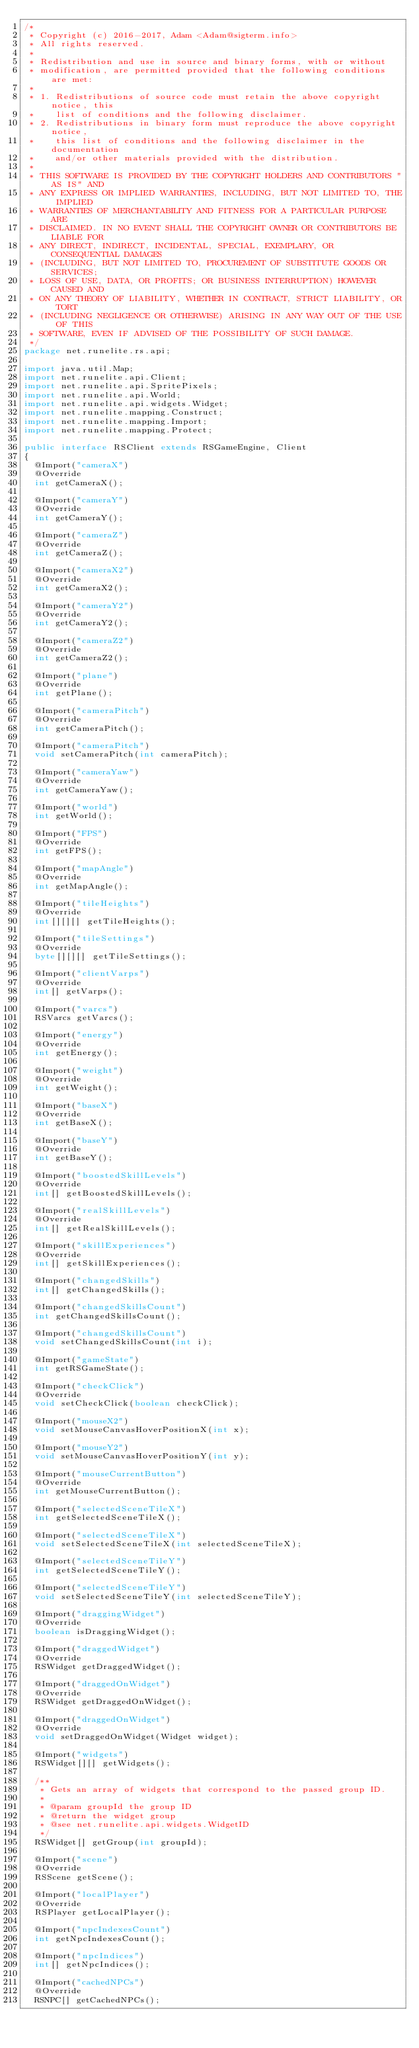<code> <loc_0><loc_0><loc_500><loc_500><_Java_>/*
 * Copyright (c) 2016-2017, Adam <Adam@sigterm.info>
 * All rights reserved.
 *
 * Redistribution and use in source and binary forms, with or without
 * modification, are permitted provided that the following conditions are met:
 *
 * 1. Redistributions of source code must retain the above copyright notice, this
 *    list of conditions and the following disclaimer.
 * 2. Redistributions in binary form must reproduce the above copyright notice,
 *    this list of conditions and the following disclaimer in the documentation
 *    and/or other materials provided with the distribution.
 *
 * THIS SOFTWARE IS PROVIDED BY THE COPYRIGHT HOLDERS AND CONTRIBUTORS "AS IS" AND
 * ANY EXPRESS OR IMPLIED WARRANTIES, INCLUDING, BUT NOT LIMITED TO, THE IMPLIED
 * WARRANTIES OF MERCHANTABILITY AND FITNESS FOR A PARTICULAR PURPOSE ARE
 * DISCLAIMED. IN NO EVENT SHALL THE COPYRIGHT OWNER OR CONTRIBUTORS BE LIABLE FOR
 * ANY DIRECT, INDIRECT, INCIDENTAL, SPECIAL, EXEMPLARY, OR CONSEQUENTIAL DAMAGES
 * (INCLUDING, BUT NOT LIMITED TO, PROCUREMENT OF SUBSTITUTE GOODS OR SERVICES;
 * LOSS OF USE, DATA, OR PROFITS; OR BUSINESS INTERRUPTION) HOWEVER CAUSED AND
 * ON ANY THEORY OF LIABILITY, WHETHER IN CONTRACT, STRICT LIABILITY, OR TORT
 * (INCLUDING NEGLIGENCE OR OTHERWISE) ARISING IN ANY WAY OUT OF THE USE OF THIS
 * SOFTWARE, EVEN IF ADVISED OF THE POSSIBILITY OF SUCH DAMAGE.
 */
package net.runelite.rs.api;

import java.util.Map;
import net.runelite.api.Client;
import net.runelite.api.SpritePixels;
import net.runelite.api.World;
import net.runelite.api.widgets.Widget;
import net.runelite.mapping.Construct;
import net.runelite.mapping.Import;
import net.runelite.mapping.Protect;

public interface RSClient extends RSGameEngine, Client
{
	@Import("cameraX")
	@Override
	int getCameraX();

	@Import("cameraY")
	@Override
	int getCameraY();

	@Import("cameraZ")
	@Override
	int getCameraZ();

	@Import("cameraX2")
	@Override
	int getCameraX2();

	@Import("cameraY2")
	@Override
	int getCameraY2();

	@Import("cameraZ2")
	@Override
	int getCameraZ2();

	@Import("plane")
	@Override
	int getPlane();

	@Import("cameraPitch")
	@Override
	int getCameraPitch();

	@Import("cameraPitch")
	void setCameraPitch(int cameraPitch);

	@Import("cameraYaw")
	@Override
	int getCameraYaw();

	@Import("world")
	int getWorld();

	@Import("FPS")
	@Override
	int getFPS();

	@Import("mapAngle")
	@Override
	int getMapAngle();

	@Import("tileHeights")
	@Override
	int[][][] getTileHeights();

	@Import("tileSettings")
	@Override
	byte[][][] getTileSettings();

	@Import("clientVarps")
	@Override
	int[] getVarps();

	@Import("varcs")
	RSVarcs getVarcs();

	@Import("energy")
	@Override
	int getEnergy();

	@Import("weight")
	@Override
	int getWeight();

	@Import("baseX")
	@Override
	int getBaseX();

	@Import("baseY")
	@Override
	int getBaseY();

	@Import("boostedSkillLevels")
	@Override
	int[] getBoostedSkillLevels();

	@Import("realSkillLevels")
	@Override
	int[] getRealSkillLevels();

	@Import("skillExperiences")
	@Override
	int[] getSkillExperiences();

	@Import("changedSkills")
	int[] getChangedSkills();

	@Import("changedSkillsCount")
	int getChangedSkillsCount();

	@Import("changedSkillsCount")
	void setChangedSkillsCount(int i);

	@Import("gameState")
	int getRSGameState();

	@Import("checkClick")
	@Override
	void setCheckClick(boolean checkClick);

	@Import("mouseX2")
	void setMouseCanvasHoverPositionX(int x);

	@Import("mouseY2")
	void setMouseCanvasHoverPositionY(int y);

	@Import("mouseCurrentButton")
	@Override
	int getMouseCurrentButton();

	@Import("selectedSceneTileX")
	int getSelectedSceneTileX();

	@Import("selectedSceneTileX")
	void setSelectedSceneTileX(int selectedSceneTileX);

	@Import("selectedSceneTileY")
	int getSelectedSceneTileY();

	@Import("selectedSceneTileY")
	void setSelectedSceneTileY(int selectedSceneTileY);

	@Import("draggingWidget")
	@Override
	boolean isDraggingWidget();

	@Import("draggedWidget")
	@Override
	RSWidget getDraggedWidget();

	@Import("draggedOnWidget")
	@Override
	RSWidget getDraggedOnWidget();

	@Import("draggedOnWidget")
	@Override
	void setDraggedOnWidget(Widget widget);

	@Import("widgets")
	RSWidget[][] getWidgets();

	/**
	 * Gets an array of widgets that correspond to the passed group ID.
	 *
	 * @param groupId the group ID
	 * @return the widget group
	 * @see net.runelite.api.widgets.WidgetID
	 */
	RSWidget[] getGroup(int groupId);

	@Import("scene")
	@Override
	RSScene getScene();

	@Import("localPlayer")
	@Override
	RSPlayer getLocalPlayer();

	@Import("npcIndexesCount")
	int getNpcIndexesCount();

	@Import("npcIndices")
	int[] getNpcIndices();

	@Import("cachedNPCs")
	@Override
	RSNPC[] getCachedNPCs();
</code> 